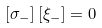<formula> <loc_0><loc_0><loc_500><loc_500>\left [ \sigma _ { - } \right ] [ \xi _ { - } ] = 0</formula> 